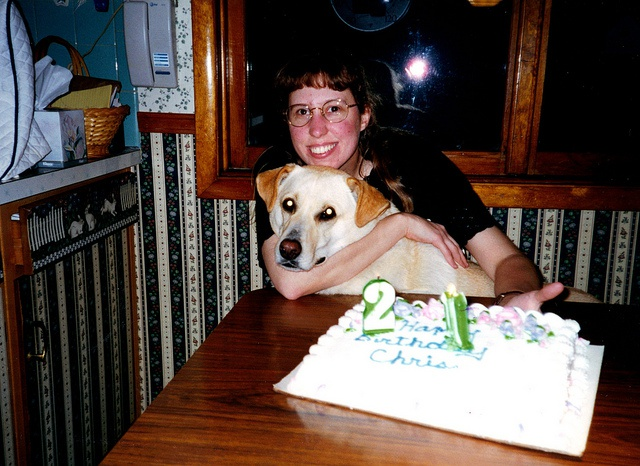Describe the objects in this image and their specific colors. I can see dining table in blue, white, maroon, black, and tan tones, cake in blue, white, lightblue, lightgreen, and green tones, people in blue, black, lightpink, brown, and maroon tones, and dog in blue, lightgray, tan, and darkgray tones in this image. 